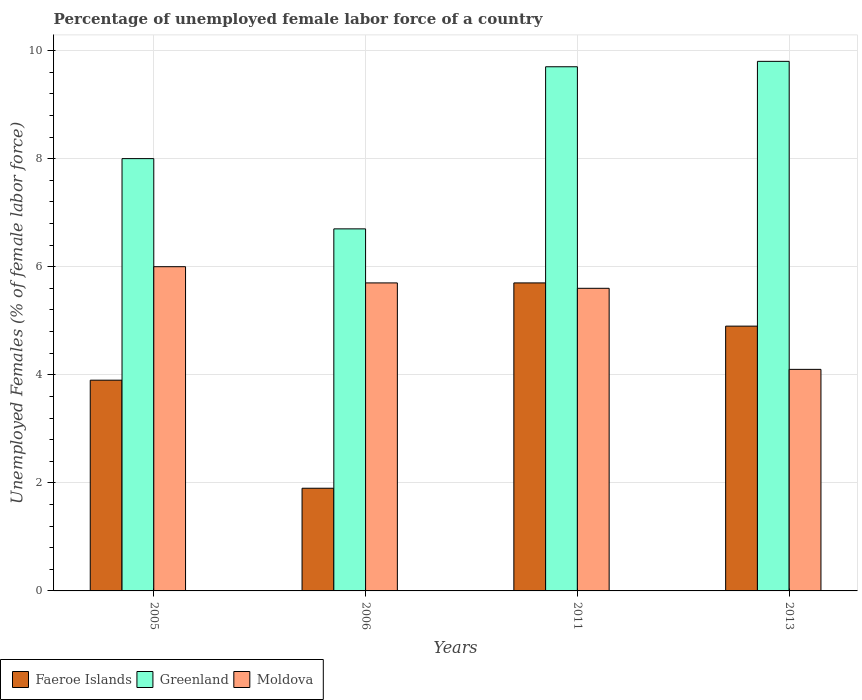How many different coloured bars are there?
Make the answer very short. 3. Are the number of bars per tick equal to the number of legend labels?
Provide a succinct answer. Yes. How many bars are there on the 4th tick from the right?
Keep it short and to the point. 3. What is the label of the 1st group of bars from the left?
Make the answer very short. 2005. In how many cases, is the number of bars for a given year not equal to the number of legend labels?
Offer a terse response. 0. What is the percentage of unemployed female labor force in Faeroe Islands in 2011?
Your answer should be compact. 5.7. Across all years, what is the maximum percentage of unemployed female labor force in Moldova?
Your answer should be compact. 6. Across all years, what is the minimum percentage of unemployed female labor force in Faeroe Islands?
Provide a short and direct response. 1.9. In which year was the percentage of unemployed female labor force in Greenland maximum?
Your answer should be very brief. 2013. What is the total percentage of unemployed female labor force in Moldova in the graph?
Keep it short and to the point. 21.4. What is the difference between the percentage of unemployed female labor force in Greenland in 2005 and that in 2006?
Make the answer very short. 1.3. What is the difference between the percentage of unemployed female labor force in Greenland in 2005 and the percentage of unemployed female labor force in Moldova in 2013?
Give a very brief answer. 3.9. What is the average percentage of unemployed female labor force in Moldova per year?
Your response must be concise. 5.35. What is the ratio of the percentage of unemployed female labor force in Moldova in 2005 to that in 2013?
Your answer should be compact. 1.46. Is the percentage of unemployed female labor force in Greenland in 2006 less than that in 2011?
Your response must be concise. Yes. Is the difference between the percentage of unemployed female labor force in Greenland in 2011 and 2013 greater than the difference between the percentage of unemployed female labor force in Moldova in 2011 and 2013?
Provide a succinct answer. No. What is the difference between the highest and the second highest percentage of unemployed female labor force in Faeroe Islands?
Give a very brief answer. 0.8. What is the difference between the highest and the lowest percentage of unemployed female labor force in Moldova?
Provide a succinct answer. 1.9. What does the 1st bar from the left in 2006 represents?
Keep it short and to the point. Faeroe Islands. What does the 1st bar from the right in 2006 represents?
Give a very brief answer. Moldova. Is it the case that in every year, the sum of the percentage of unemployed female labor force in Moldova and percentage of unemployed female labor force in Faeroe Islands is greater than the percentage of unemployed female labor force in Greenland?
Give a very brief answer. No. How many bars are there?
Offer a terse response. 12. How many years are there in the graph?
Offer a very short reply. 4. How many legend labels are there?
Your response must be concise. 3. What is the title of the graph?
Provide a short and direct response. Percentage of unemployed female labor force of a country. What is the label or title of the X-axis?
Ensure brevity in your answer.  Years. What is the label or title of the Y-axis?
Make the answer very short. Unemployed Females (% of female labor force). What is the Unemployed Females (% of female labor force) in Faeroe Islands in 2005?
Give a very brief answer. 3.9. What is the Unemployed Females (% of female labor force) in Greenland in 2005?
Ensure brevity in your answer.  8. What is the Unemployed Females (% of female labor force) of Moldova in 2005?
Make the answer very short. 6. What is the Unemployed Females (% of female labor force) of Faeroe Islands in 2006?
Offer a very short reply. 1.9. What is the Unemployed Females (% of female labor force) in Greenland in 2006?
Provide a succinct answer. 6.7. What is the Unemployed Females (% of female labor force) in Moldova in 2006?
Your answer should be very brief. 5.7. What is the Unemployed Females (% of female labor force) in Faeroe Islands in 2011?
Offer a terse response. 5.7. What is the Unemployed Females (% of female labor force) of Greenland in 2011?
Give a very brief answer. 9.7. What is the Unemployed Females (% of female labor force) of Moldova in 2011?
Offer a terse response. 5.6. What is the Unemployed Females (% of female labor force) in Faeroe Islands in 2013?
Offer a very short reply. 4.9. What is the Unemployed Females (% of female labor force) in Greenland in 2013?
Ensure brevity in your answer.  9.8. What is the Unemployed Females (% of female labor force) of Moldova in 2013?
Your answer should be compact. 4.1. Across all years, what is the maximum Unemployed Females (% of female labor force) in Faeroe Islands?
Your answer should be very brief. 5.7. Across all years, what is the maximum Unemployed Females (% of female labor force) in Greenland?
Your answer should be very brief. 9.8. Across all years, what is the maximum Unemployed Females (% of female labor force) in Moldova?
Offer a very short reply. 6. Across all years, what is the minimum Unemployed Females (% of female labor force) in Faeroe Islands?
Keep it short and to the point. 1.9. Across all years, what is the minimum Unemployed Females (% of female labor force) in Greenland?
Your answer should be very brief. 6.7. Across all years, what is the minimum Unemployed Females (% of female labor force) of Moldova?
Provide a short and direct response. 4.1. What is the total Unemployed Females (% of female labor force) in Greenland in the graph?
Give a very brief answer. 34.2. What is the total Unemployed Females (% of female labor force) of Moldova in the graph?
Keep it short and to the point. 21.4. What is the difference between the Unemployed Females (% of female labor force) of Faeroe Islands in 2005 and that in 2006?
Ensure brevity in your answer.  2. What is the difference between the Unemployed Females (% of female labor force) in Greenland in 2005 and that in 2006?
Your answer should be very brief. 1.3. What is the difference between the Unemployed Females (% of female labor force) of Faeroe Islands in 2005 and that in 2011?
Provide a short and direct response. -1.8. What is the difference between the Unemployed Females (% of female labor force) in Faeroe Islands in 2005 and that in 2013?
Provide a short and direct response. -1. What is the difference between the Unemployed Females (% of female labor force) in Greenland in 2005 and that in 2013?
Your answer should be very brief. -1.8. What is the difference between the Unemployed Females (% of female labor force) of Moldova in 2005 and that in 2013?
Keep it short and to the point. 1.9. What is the difference between the Unemployed Females (% of female labor force) in Faeroe Islands in 2006 and that in 2011?
Offer a terse response. -3.8. What is the difference between the Unemployed Females (% of female labor force) of Greenland in 2006 and that in 2011?
Make the answer very short. -3. What is the difference between the Unemployed Females (% of female labor force) in Faeroe Islands in 2006 and that in 2013?
Make the answer very short. -3. What is the difference between the Unemployed Females (% of female labor force) in Faeroe Islands in 2011 and that in 2013?
Provide a short and direct response. 0.8. What is the difference between the Unemployed Females (% of female labor force) in Moldova in 2011 and that in 2013?
Give a very brief answer. 1.5. What is the difference between the Unemployed Females (% of female labor force) of Faeroe Islands in 2005 and the Unemployed Females (% of female labor force) of Greenland in 2006?
Provide a succinct answer. -2.8. What is the difference between the Unemployed Females (% of female labor force) of Faeroe Islands in 2005 and the Unemployed Females (% of female labor force) of Moldova in 2011?
Offer a very short reply. -1.7. What is the difference between the Unemployed Females (% of female labor force) in Faeroe Islands in 2005 and the Unemployed Females (% of female labor force) in Moldova in 2013?
Give a very brief answer. -0.2. What is the difference between the Unemployed Females (% of female labor force) of Faeroe Islands in 2006 and the Unemployed Females (% of female labor force) of Greenland in 2011?
Your answer should be very brief. -7.8. What is the difference between the Unemployed Females (% of female labor force) in Faeroe Islands in 2006 and the Unemployed Females (% of female labor force) in Greenland in 2013?
Provide a succinct answer. -7.9. What is the difference between the Unemployed Females (% of female labor force) of Faeroe Islands in 2011 and the Unemployed Females (% of female labor force) of Greenland in 2013?
Your response must be concise. -4.1. What is the average Unemployed Females (% of female labor force) in Greenland per year?
Your response must be concise. 8.55. What is the average Unemployed Females (% of female labor force) of Moldova per year?
Provide a short and direct response. 5.35. In the year 2005, what is the difference between the Unemployed Females (% of female labor force) in Faeroe Islands and Unemployed Females (% of female labor force) in Greenland?
Offer a very short reply. -4.1. In the year 2005, what is the difference between the Unemployed Females (% of female labor force) in Greenland and Unemployed Females (% of female labor force) in Moldova?
Provide a short and direct response. 2. In the year 2006, what is the difference between the Unemployed Females (% of female labor force) in Faeroe Islands and Unemployed Females (% of female labor force) in Greenland?
Keep it short and to the point. -4.8. In the year 2006, what is the difference between the Unemployed Females (% of female labor force) in Greenland and Unemployed Females (% of female labor force) in Moldova?
Keep it short and to the point. 1. In the year 2011, what is the difference between the Unemployed Females (% of female labor force) in Faeroe Islands and Unemployed Females (% of female labor force) in Greenland?
Provide a succinct answer. -4. In the year 2011, what is the difference between the Unemployed Females (% of female labor force) of Faeroe Islands and Unemployed Females (% of female labor force) of Moldova?
Provide a succinct answer. 0.1. In the year 2011, what is the difference between the Unemployed Females (% of female labor force) in Greenland and Unemployed Females (% of female labor force) in Moldova?
Your answer should be compact. 4.1. In the year 2013, what is the difference between the Unemployed Females (% of female labor force) in Faeroe Islands and Unemployed Females (% of female labor force) in Greenland?
Ensure brevity in your answer.  -4.9. In the year 2013, what is the difference between the Unemployed Females (% of female labor force) in Greenland and Unemployed Females (% of female labor force) in Moldova?
Your answer should be very brief. 5.7. What is the ratio of the Unemployed Females (% of female labor force) in Faeroe Islands in 2005 to that in 2006?
Ensure brevity in your answer.  2.05. What is the ratio of the Unemployed Females (% of female labor force) of Greenland in 2005 to that in 2006?
Offer a very short reply. 1.19. What is the ratio of the Unemployed Females (% of female labor force) in Moldova in 2005 to that in 2006?
Ensure brevity in your answer.  1.05. What is the ratio of the Unemployed Females (% of female labor force) in Faeroe Islands in 2005 to that in 2011?
Your answer should be very brief. 0.68. What is the ratio of the Unemployed Females (% of female labor force) in Greenland in 2005 to that in 2011?
Give a very brief answer. 0.82. What is the ratio of the Unemployed Females (% of female labor force) in Moldova in 2005 to that in 2011?
Keep it short and to the point. 1.07. What is the ratio of the Unemployed Females (% of female labor force) in Faeroe Islands in 2005 to that in 2013?
Your response must be concise. 0.8. What is the ratio of the Unemployed Females (% of female labor force) of Greenland in 2005 to that in 2013?
Offer a very short reply. 0.82. What is the ratio of the Unemployed Females (% of female labor force) in Moldova in 2005 to that in 2013?
Offer a very short reply. 1.46. What is the ratio of the Unemployed Females (% of female labor force) in Faeroe Islands in 2006 to that in 2011?
Provide a short and direct response. 0.33. What is the ratio of the Unemployed Females (% of female labor force) in Greenland in 2006 to that in 2011?
Your answer should be compact. 0.69. What is the ratio of the Unemployed Females (% of female labor force) of Moldova in 2006 to that in 2011?
Your response must be concise. 1.02. What is the ratio of the Unemployed Females (% of female labor force) of Faeroe Islands in 2006 to that in 2013?
Provide a succinct answer. 0.39. What is the ratio of the Unemployed Females (% of female labor force) of Greenland in 2006 to that in 2013?
Offer a terse response. 0.68. What is the ratio of the Unemployed Females (% of female labor force) in Moldova in 2006 to that in 2013?
Your response must be concise. 1.39. What is the ratio of the Unemployed Females (% of female labor force) in Faeroe Islands in 2011 to that in 2013?
Your response must be concise. 1.16. What is the ratio of the Unemployed Females (% of female labor force) of Moldova in 2011 to that in 2013?
Offer a terse response. 1.37. What is the difference between the highest and the second highest Unemployed Females (% of female labor force) of Faeroe Islands?
Keep it short and to the point. 0.8. What is the difference between the highest and the second highest Unemployed Females (% of female labor force) in Moldova?
Your answer should be very brief. 0.3. What is the difference between the highest and the lowest Unemployed Females (% of female labor force) in Faeroe Islands?
Keep it short and to the point. 3.8. What is the difference between the highest and the lowest Unemployed Females (% of female labor force) of Moldova?
Give a very brief answer. 1.9. 